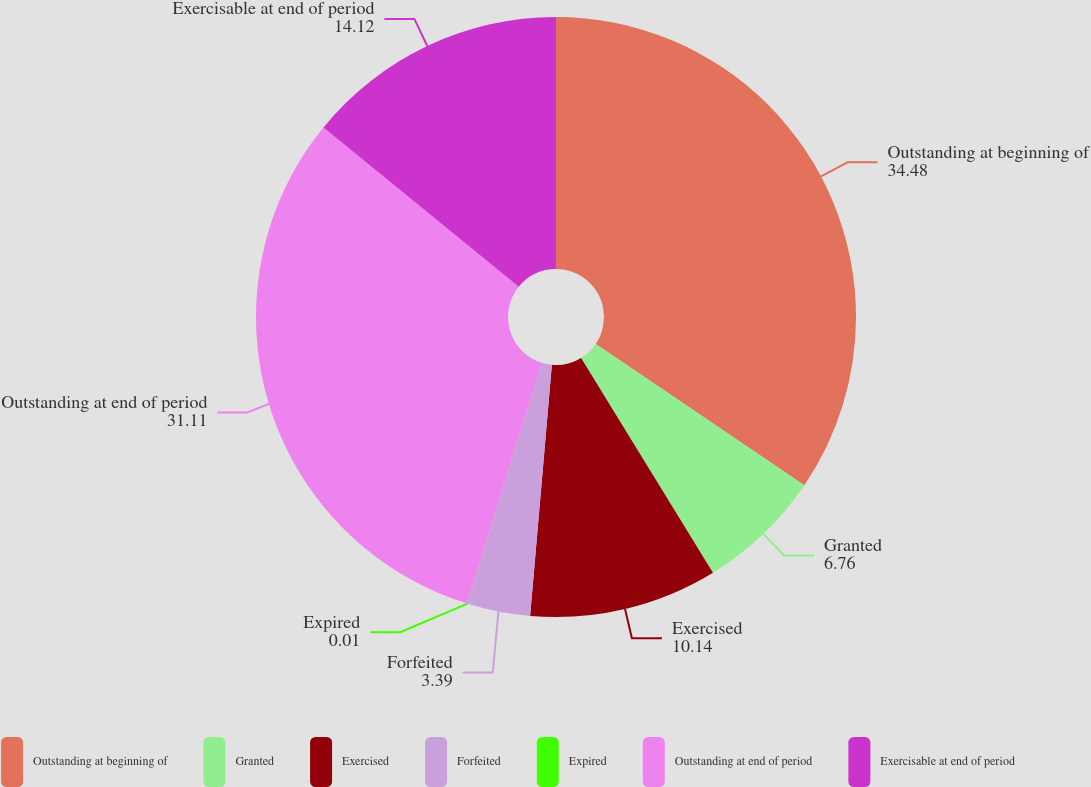<chart> <loc_0><loc_0><loc_500><loc_500><pie_chart><fcel>Outstanding at beginning of<fcel>Granted<fcel>Exercised<fcel>Forfeited<fcel>Expired<fcel>Outstanding at end of period<fcel>Exercisable at end of period<nl><fcel>34.48%<fcel>6.76%<fcel>10.14%<fcel>3.39%<fcel>0.01%<fcel>31.11%<fcel>14.12%<nl></chart> 